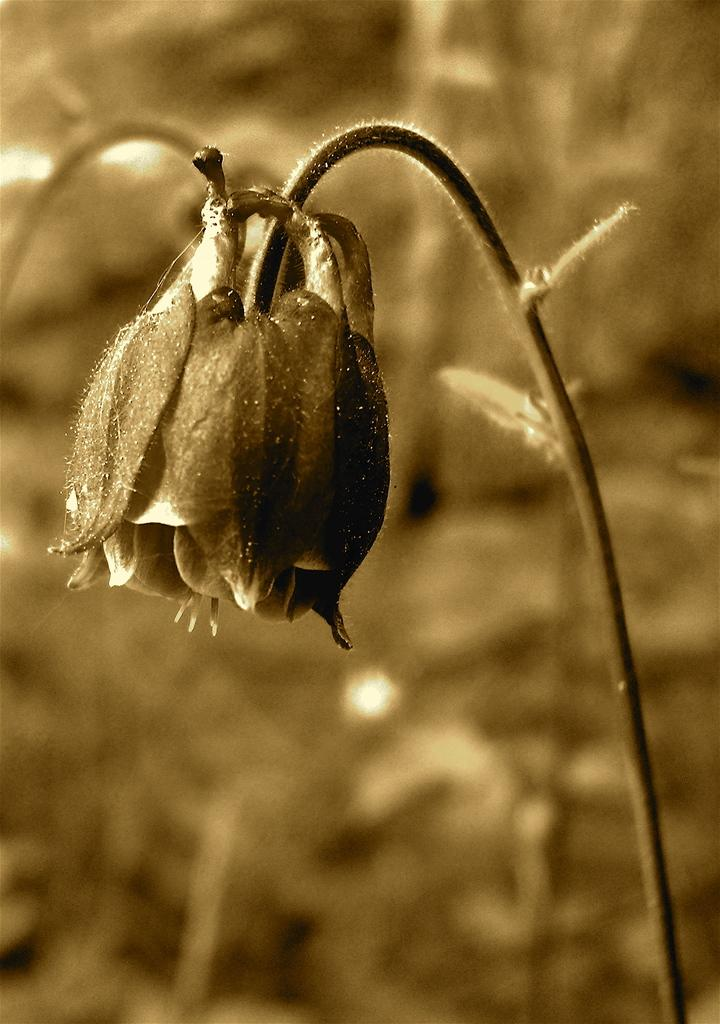What is the main subject of the image? There is a flower in the image. Can you describe the background of the image? The background appears blurry. How does the flower express regret in the image? The flower does not express regret in the image, as it is an inanimate object and cannot experience emotions like regret. 